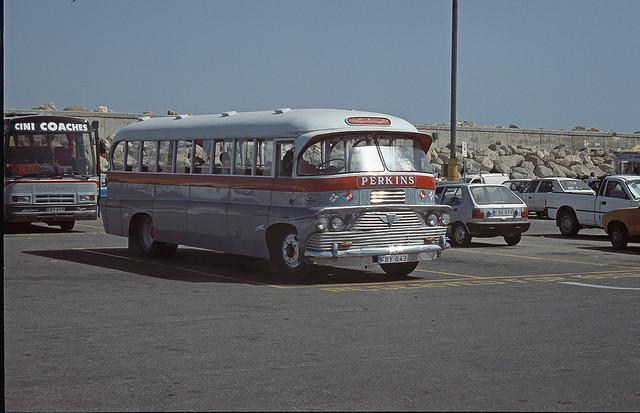What country's red white flag is on the Perkins bus?

Choices:
A) honduras
B) guatemala
C) peru
D) mexico peru 